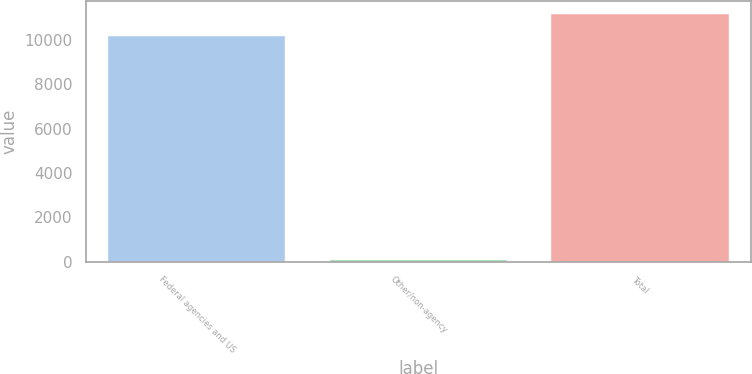Convert chart to OTSL. <chart><loc_0><loc_0><loc_500><loc_500><bar_chart><fcel>Federal agencies and US<fcel>Other/non-agency<fcel>Total<nl><fcel>10163<fcel>55<fcel>11179.3<nl></chart> 